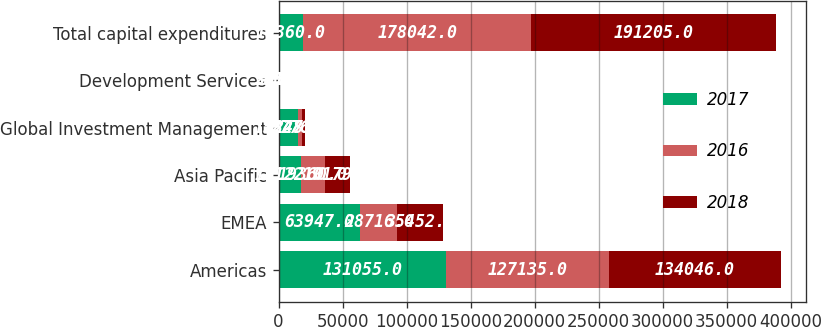Convert chart to OTSL. <chart><loc_0><loc_0><loc_500><loc_500><stacked_bar_chart><ecel><fcel>Americas<fcel>EMEA<fcel>Asia Pacific<fcel>Global Investment Management<fcel>Development Services<fcel>Total capital expenditures<nl><fcel>2017<fcel>131055<fcel>63947<fcel>17122<fcel>15348<fcel>331<fcel>19360<nl><fcel>2016<fcel>127135<fcel>28716<fcel>19360<fcel>2776<fcel>55<fcel>178042<nl><fcel>2018<fcel>134046<fcel>35452<fcel>19179<fcel>2273<fcel>255<fcel>191205<nl></chart> 